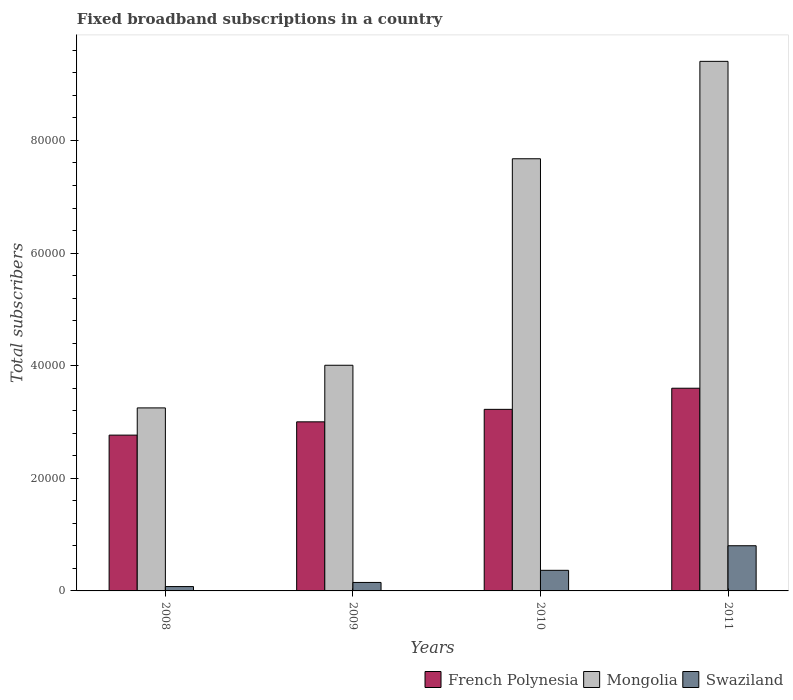How many different coloured bars are there?
Make the answer very short. 3. Are the number of bars per tick equal to the number of legend labels?
Give a very brief answer. Yes. What is the number of broadband subscriptions in Mongolia in 2009?
Provide a short and direct response. 4.01e+04. Across all years, what is the maximum number of broadband subscriptions in French Polynesia?
Give a very brief answer. 3.60e+04. Across all years, what is the minimum number of broadband subscriptions in Mongolia?
Keep it short and to the point. 3.25e+04. In which year was the number of broadband subscriptions in French Polynesia minimum?
Provide a short and direct response. 2008. What is the total number of broadband subscriptions in Swaziland in the graph?
Make the answer very short. 1.40e+04. What is the difference between the number of broadband subscriptions in Mongolia in 2010 and that in 2011?
Keep it short and to the point. -1.73e+04. What is the difference between the number of broadband subscriptions in French Polynesia in 2011 and the number of broadband subscriptions in Mongolia in 2009?
Offer a terse response. -4077. What is the average number of broadband subscriptions in Swaziland per year?
Your response must be concise. 3489.5. In the year 2010, what is the difference between the number of broadband subscriptions in French Polynesia and number of broadband subscriptions in Swaziland?
Make the answer very short. 2.86e+04. In how many years, is the number of broadband subscriptions in French Polynesia greater than 48000?
Make the answer very short. 0. What is the ratio of the number of broadband subscriptions in French Polynesia in 2010 to that in 2011?
Ensure brevity in your answer.  0.9. Is the number of broadband subscriptions in Mongolia in 2009 less than that in 2011?
Give a very brief answer. Yes. Is the difference between the number of broadband subscriptions in French Polynesia in 2008 and 2009 greater than the difference between the number of broadband subscriptions in Swaziland in 2008 and 2009?
Provide a succinct answer. No. What is the difference between the highest and the second highest number of broadband subscriptions in Swaziland?
Your answer should be very brief. 4366. What is the difference between the highest and the lowest number of broadband subscriptions in French Polynesia?
Offer a terse response. 8329. In how many years, is the number of broadband subscriptions in Swaziland greater than the average number of broadband subscriptions in Swaziland taken over all years?
Ensure brevity in your answer.  2. Is the sum of the number of broadband subscriptions in French Polynesia in 2009 and 2011 greater than the maximum number of broadband subscriptions in Mongolia across all years?
Provide a short and direct response. No. What does the 3rd bar from the left in 2009 represents?
Your response must be concise. Swaziland. What does the 3rd bar from the right in 2009 represents?
Your answer should be very brief. French Polynesia. Are the values on the major ticks of Y-axis written in scientific E-notation?
Offer a very short reply. No. Where does the legend appear in the graph?
Offer a very short reply. Bottom right. How many legend labels are there?
Offer a terse response. 3. How are the legend labels stacked?
Offer a terse response. Horizontal. What is the title of the graph?
Your response must be concise. Fixed broadband subscriptions in a country. What is the label or title of the X-axis?
Provide a succinct answer. Years. What is the label or title of the Y-axis?
Provide a succinct answer. Total subscribers. What is the Total subscribers in French Polynesia in 2008?
Your response must be concise. 2.77e+04. What is the Total subscribers of Mongolia in 2008?
Make the answer very short. 3.25e+04. What is the Total subscribers in Swaziland in 2008?
Ensure brevity in your answer.  772. What is the Total subscribers in French Polynesia in 2009?
Your answer should be very brief. 3.00e+04. What is the Total subscribers in Mongolia in 2009?
Give a very brief answer. 4.01e+04. What is the Total subscribers of Swaziland in 2009?
Provide a succinct answer. 1504. What is the Total subscribers in French Polynesia in 2010?
Make the answer very short. 3.22e+04. What is the Total subscribers of Mongolia in 2010?
Ensure brevity in your answer.  7.68e+04. What is the Total subscribers in Swaziland in 2010?
Provide a short and direct response. 3658. What is the Total subscribers in French Polynesia in 2011?
Make the answer very short. 3.60e+04. What is the Total subscribers of Mongolia in 2011?
Offer a very short reply. 9.41e+04. What is the Total subscribers in Swaziland in 2011?
Your response must be concise. 8024. Across all years, what is the maximum Total subscribers in French Polynesia?
Your answer should be very brief. 3.60e+04. Across all years, what is the maximum Total subscribers of Mongolia?
Your answer should be compact. 9.41e+04. Across all years, what is the maximum Total subscribers in Swaziland?
Your answer should be compact. 8024. Across all years, what is the minimum Total subscribers of French Polynesia?
Keep it short and to the point. 2.77e+04. Across all years, what is the minimum Total subscribers of Mongolia?
Ensure brevity in your answer.  3.25e+04. Across all years, what is the minimum Total subscribers in Swaziland?
Ensure brevity in your answer.  772. What is the total Total subscribers in French Polynesia in the graph?
Your response must be concise. 1.26e+05. What is the total Total subscribers in Mongolia in the graph?
Offer a very short reply. 2.43e+05. What is the total Total subscribers in Swaziland in the graph?
Provide a short and direct response. 1.40e+04. What is the difference between the Total subscribers of French Polynesia in 2008 and that in 2009?
Make the answer very short. -2359. What is the difference between the Total subscribers of Mongolia in 2008 and that in 2009?
Provide a succinct answer. -7573. What is the difference between the Total subscribers of Swaziland in 2008 and that in 2009?
Provide a succinct answer. -732. What is the difference between the Total subscribers of French Polynesia in 2008 and that in 2010?
Make the answer very short. -4576. What is the difference between the Total subscribers of Mongolia in 2008 and that in 2010?
Make the answer very short. -4.42e+04. What is the difference between the Total subscribers in Swaziland in 2008 and that in 2010?
Your response must be concise. -2886. What is the difference between the Total subscribers in French Polynesia in 2008 and that in 2011?
Provide a succinct answer. -8329. What is the difference between the Total subscribers of Mongolia in 2008 and that in 2011?
Offer a terse response. -6.15e+04. What is the difference between the Total subscribers of Swaziland in 2008 and that in 2011?
Give a very brief answer. -7252. What is the difference between the Total subscribers in French Polynesia in 2009 and that in 2010?
Your response must be concise. -2217. What is the difference between the Total subscribers in Mongolia in 2009 and that in 2010?
Offer a very short reply. -3.67e+04. What is the difference between the Total subscribers in Swaziland in 2009 and that in 2010?
Your response must be concise. -2154. What is the difference between the Total subscribers of French Polynesia in 2009 and that in 2011?
Your response must be concise. -5970. What is the difference between the Total subscribers in Mongolia in 2009 and that in 2011?
Keep it short and to the point. -5.40e+04. What is the difference between the Total subscribers in Swaziland in 2009 and that in 2011?
Offer a very short reply. -6520. What is the difference between the Total subscribers of French Polynesia in 2010 and that in 2011?
Your answer should be compact. -3753. What is the difference between the Total subscribers in Mongolia in 2010 and that in 2011?
Make the answer very short. -1.73e+04. What is the difference between the Total subscribers of Swaziland in 2010 and that in 2011?
Offer a very short reply. -4366. What is the difference between the Total subscribers of French Polynesia in 2008 and the Total subscribers of Mongolia in 2009?
Keep it short and to the point. -1.24e+04. What is the difference between the Total subscribers of French Polynesia in 2008 and the Total subscribers of Swaziland in 2009?
Your answer should be very brief. 2.62e+04. What is the difference between the Total subscribers of Mongolia in 2008 and the Total subscribers of Swaziland in 2009?
Make the answer very short. 3.10e+04. What is the difference between the Total subscribers of French Polynesia in 2008 and the Total subscribers of Mongolia in 2010?
Your response must be concise. -4.91e+04. What is the difference between the Total subscribers of French Polynesia in 2008 and the Total subscribers of Swaziland in 2010?
Your answer should be very brief. 2.40e+04. What is the difference between the Total subscribers in Mongolia in 2008 and the Total subscribers in Swaziland in 2010?
Provide a succinct answer. 2.88e+04. What is the difference between the Total subscribers in French Polynesia in 2008 and the Total subscribers in Mongolia in 2011?
Your answer should be compact. -6.64e+04. What is the difference between the Total subscribers in French Polynesia in 2008 and the Total subscribers in Swaziland in 2011?
Ensure brevity in your answer.  1.96e+04. What is the difference between the Total subscribers in Mongolia in 2008 and the Total subscribers in Swaziland in 2011?
Your answer should be compact. 2.45e+04. What is the difference between the Total subscribers in French Polynesia in 2009 and the Total subscribers in Mongolia in 2010?
Offer a terse response. -4.67e+04. What is the difference between the Total subscribers in French Polynesia in 2009 and the Total subscribers in Swaziland in 2010?
Ensure brevity in your answer.  2.64e+04. What is the difference between the Total subscribers of Mongolia in 2009 and the Total subscribers of Swaziland in 2010?
Provide a succinct answer. 3.64e+04. What is the difference between the Total subscribers in French Polynesia in 2009 and the Total subscribers in Mongolia in 2011?
Your response must be concise. -6.40e+04. What is the difference between the Total subscribers in French Polynesia in 2009 and the Total subscribers in Swaziland in 2011?
Provide a succinct answer. 2.20e+04. What is the difference between the Total subscribers in Mongolia in 2009 and the Total subscribers in Swaziland in 2011?
Ensure brevity in your answer.  3.21e+04. What is the difference between the Total subscribers in French Polynesia in 2010 and the Total subscribers in Mongolia in 2011?
Ensure brevity in your answer.  -6.18e+04. What is the difference between the Total subscribers in French Polynesia in 2010 and the Total subscribers in Swaziland in 2011?
Ensure brevity in your answer.  2.42e+04. What is the difference between the Total subscribers in Mongolia in 2010 and the Total subscribers in Swaziland in 2011?
Offer a terse response. 6.87e+04. What is the average Total subscribers of French Polynesia per year?
Make the answer very short. 3.15e+04. What is the average Total subscribers of Mongolia per year?
Make the answer very short. 6.08e+04. What is the average Total subscribers of Swaziland per year?
Offer a very short reply. 3489.5. In the year 2008, what is the difference between the Total subscribers of French Polynesia and Total subscribers of Mongolia?
Make the answer very short. -4833. In the year 2008, what is the difference between the Total subscribers of French Polynesia and Total subscribers of Swaziland?
Give a very brief answer. 2.69e+04. In the year 2008, what is the difference between the Total subscribers of Mongolia and Total subscribers of Swaziland?
Offer a terse response. 3.17e+04. In the year 2009, what is the difference between the Total subscribers of French Polynesia and Total subscribers of Mongolia?
Ensure brevity in your answer.  -1.00e+04. In the year 2009, what is the difference between the Total subscribers in French Polynesia and Total subscribers in Swaziland?
Provide a short and direct response. 2.85e+04. In the year 2009, what is the difference between the Total subscribers of Mongolia and Total subscribers of Swaziland?
Ensure brevity in your answer.  3.86e+04. In the year 2010, what is the difference between the Total subscribers of French Polynesia and Total subscribers of Mongolia?
Provide a succinct answer. -4.45e+04. In the year 2010, what is the difference between the Total subscribers of French Polynesia and Total subscribers of Swaziland?
Provide a succinct answer. 2.86e+04. In the year 2010, what is the difference between the Total subscribers of Mongolia and Total subscribers of Swaziland?
Your answer should be compact. 7.31e+04. In the year 2011, what is the difference between the Total subscribers in French Polynesia and Total subscribers in Mongolia?
Keep it short and to the point. -5.81e+04. In the year 2011, what is the difference between the Total subscribers of French Polynesia and Total subscribers of Swaziland?
Ensure brevity in your answer.  2.80e+04. In the year 2011, what is the difference between the Total subscribers in Mongolia and Total subscribers in Swaziland?
Your answer should be compact. 8.60e+04. What is the ratio of the Total subscribers in French Polynesia in 2008 to that in 2009?
Your response must be concise. 0.92. What is the ratio of the Total subscribers in Mongolia in 2008 to that in 2009?
Make the answer very short. 0.81. What is the ratio of the Total subscribers of Swaziland in 2008 to that in 2009?
Offer a terse response. 0.51. What is the ratio of the Total subscribers of French Polynesia in 2008 to that in 2010?
Your answer should be compact. 0.86. What is the ratio of the Total subscribers in Mongolia in 2008 to that in 2010?
Keep it short and to the point. 0.42. What is the ratio of the Total subscribers in Swaziland in 2008 to that in 2010?
Ensure brevity in your answer.  0.21. What is the ratio of the Total subscribers in French Polynesia in 2008 to that in 2011?
Keep it short and to the point. 0.77. What is the ratio of the Total subscribers in Mongolia in 2008 to that in 2011?
Provide a short and direct response. 0.35. What is the ratio of the Total subscribers of Swaziland in 2008 to that in 2011?
Your answer should be compact. 0.1. What is the ratio of the Total subscribers of French Polynesia in 2009 to that in 2010?
Keep it short and to the point. 0.93. What is the ratio of the Total subscribers of Mongolia in 2009 to that in 2010?
Provide a succinct answer. 0.52. What is the ratio of the Total subscribers of Swaziland in 2009 to that in 2010?
Ensure brevity in your answer.  0.41. What is the ratio of the Total subscribers in French Polynesia in 2009 to that in 2011?
Provide a succinct answer. 0.83. What is the ratio of the Total subscribers in Mongolia in 2009 to that in 2011?
Provide a short and direct response. 0.43. What is the ratio of the Total subscribers in Swaziland in 2009 to that in 2011?
Offer a very short reply. 0.19. What is the ratio of the Total subscribers in French Polynesia in 2010 to that in 2011?
Offer a very short reply. 0.9. What is the ratio of the Total subscribers of Mongolia in 2010 to that in 2011?
Provide a succinct answer. 0.82. What is the ratio of the Total subscribers in Swaziland in 2010 to that in 2011?
Offer a terse response. 0.46. What is the difference between the highest and the second highest Total subscribers in French Polynesia?
Make the answer very short. 3753. What is the difference between the highest and the second highest Total subscribers of Mongolia?
Your response must be concise. 1.73e+04. What is the difference between the highest and the second highest Total subscribers in Swaziland?
Your answer should be very brief. 4366. What is the difference between the highest and the lowest Total subscribers of French Polynesia?
Offer a very short reply. 8329. What is the difference between the highest and the lowest Total subscribers in Mongolia?
Offer a very short reply. 6.15e+04. What is the difference between the highest and the lowest Total subscribers in Swaziland?
Ensure brevity in your answer.  7252. 